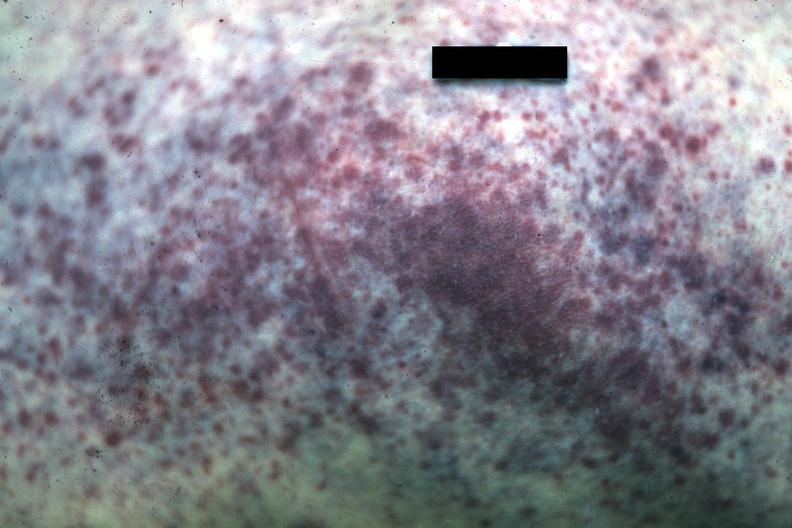s petechiae present?
Answer the question using a single word or phrase. Yes 